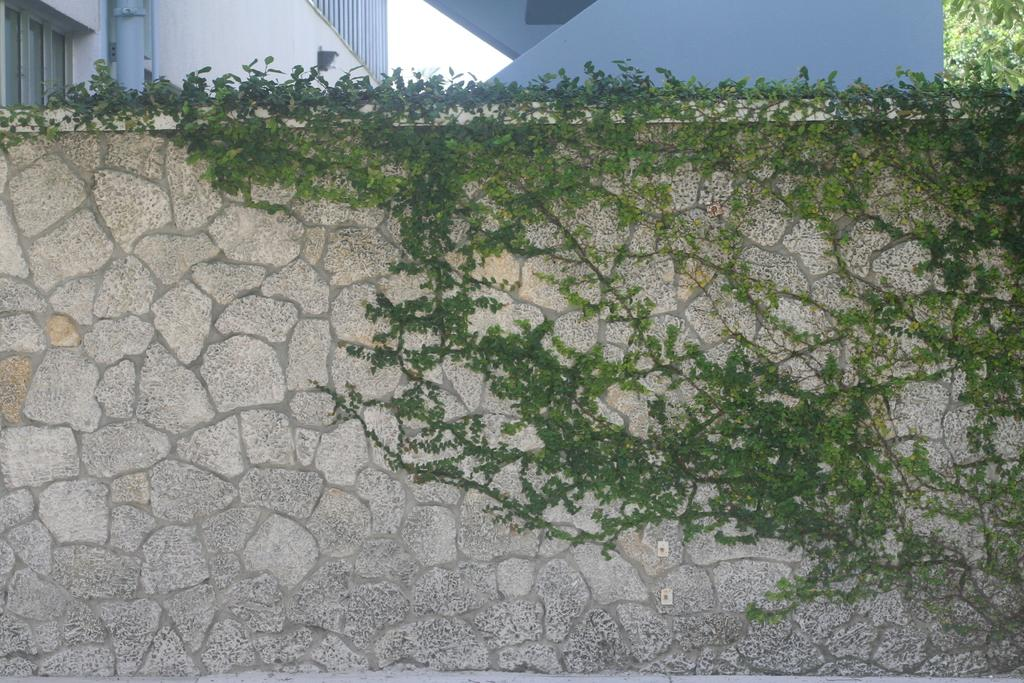What is depicted on the wall in the image? There are planets depicted on a wall in the image. What type of structures can be seen in the background of the image? There are buildings with windows in the background of the image. What can be seen in the background of the image besides buildings? There is a pipe visible in the background of the image. What type of vegetation is present at the top of the image? Trees are present at the top of the image. What is visible at the top of the image besides trees? The sky is visible at the top of the image. Can you tell me how many tails are visible on the planets in the image? There are no tails visible on the planets in the image, as planets do not have tails. What emotion is being expressed by the planets in the image? The planets in the image do not express emotions, as they are inanimate objects. 